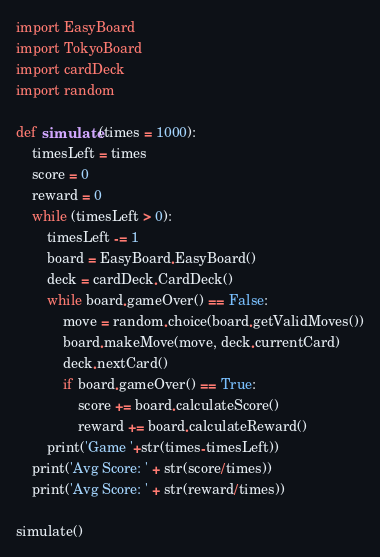<code> <loc_0><loc_0><loc_500><loc_500><_Python_>import EasyBoard
import TokyoBoard
import cardDeck
import random

def simulate(times = 1000):
    timesLeft = times
    score = 0
    reward = 0
    while (timesLeft > 0):
        timesLeft -= 1
        board = EasyBoard.EasyBoard()
        deck = cardDeck.CardDeck()
        while board.gameOver() == False:
            move = random.choice(board.getValidMoves())
            board.makeMove(move, deck.currentCard)
            deck.nextCard()
            if board.gameOver() == True:
                score += board.calculateScore()
                reward += board.calculateReward()
        print('Game '+str(times-timesLeft))
    print('Avg Score: ' + str(score/times))
    print('Avg Score: ' + str(reward/times))

simulate()
</code> 